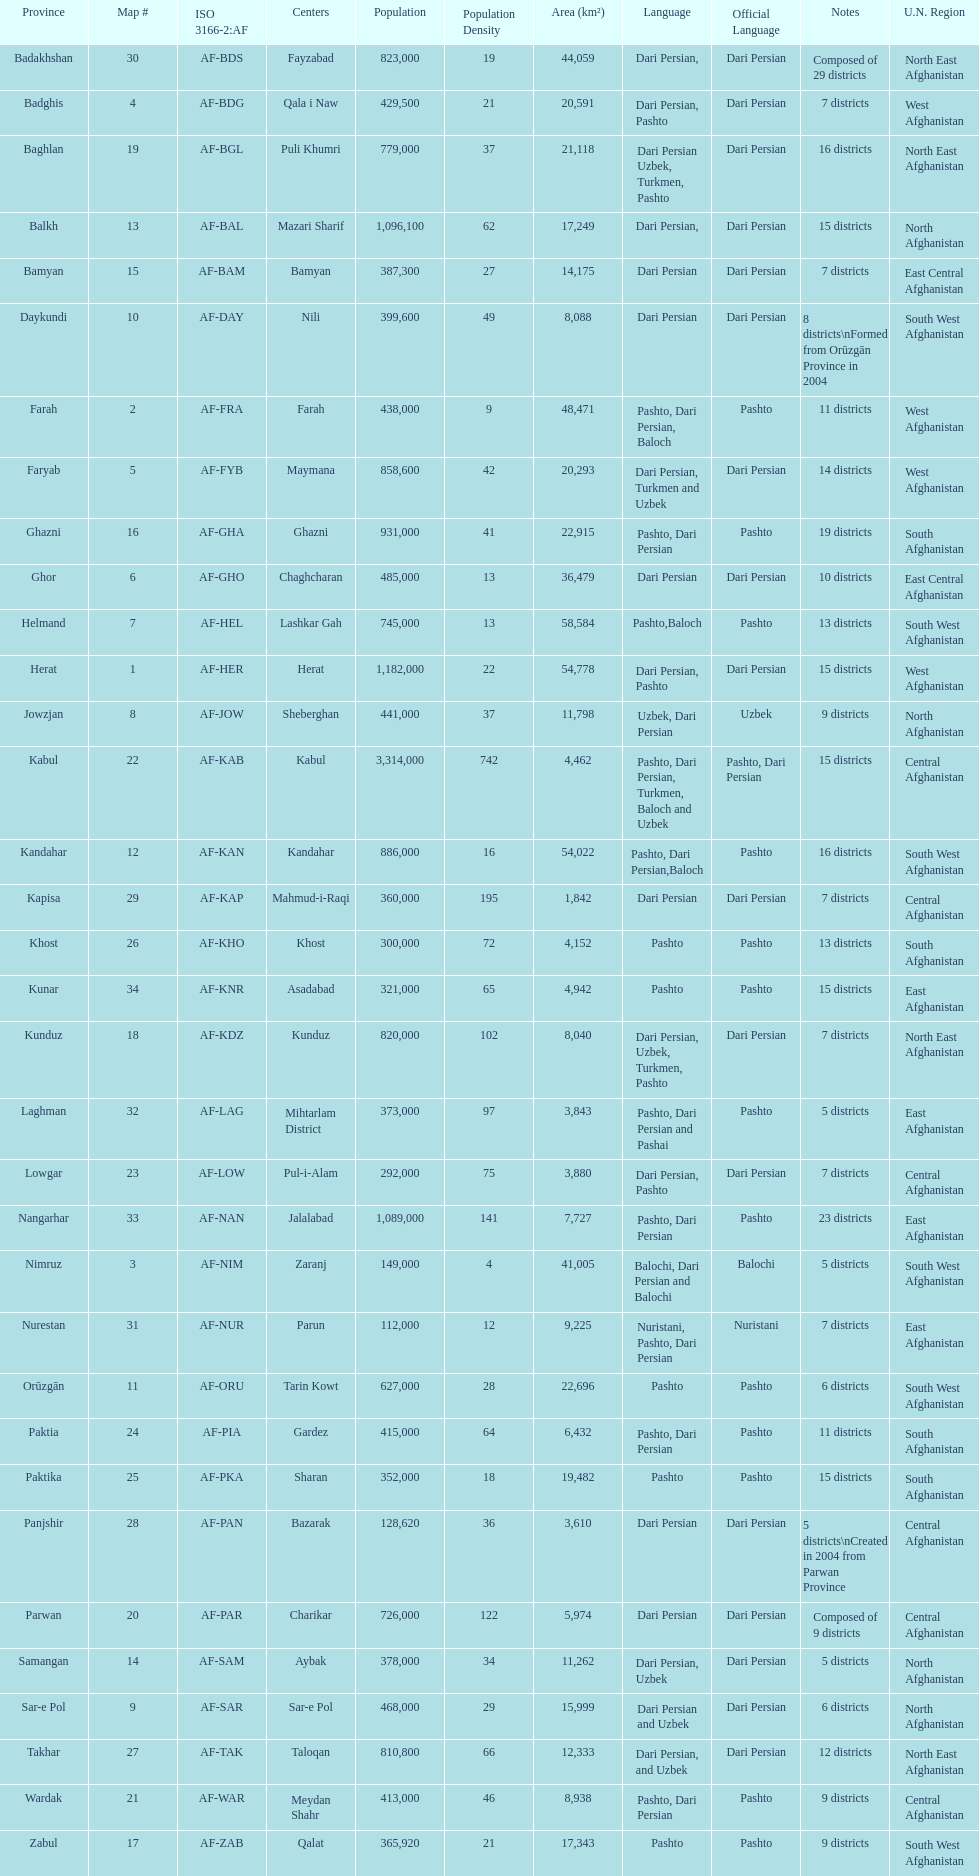Herat has a population of 1,182,000, can you list their languages Dari Persian, Pashto. 